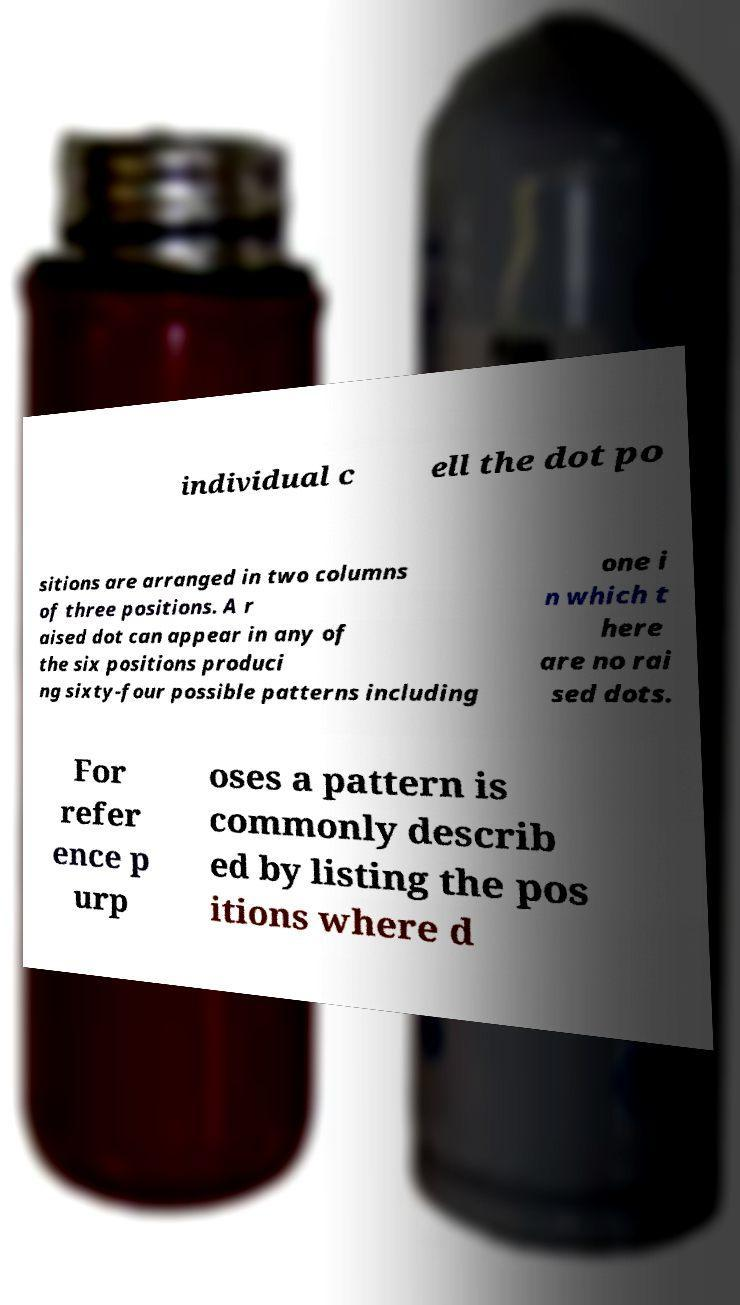Could you extract and type out the text from this image? individual c ell the dot po sitions are arranged in two columns of three positions. A r aised dot can appear in any of the six positions produci ng sixty-four possible patterns including one i n which t here are no rai sed dots. For refer ence p urp oses a pattern is commonly describ ed by listing the pos itions where d 